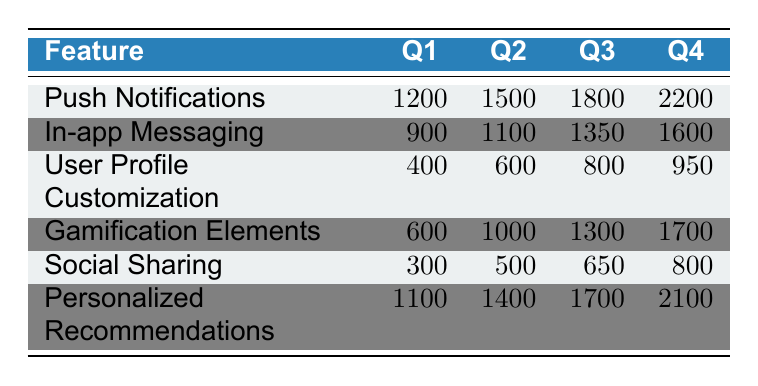What was the user engagement level for Push Notifications in Q3? Referring to the table, the engagement level for Push Notifications in Q3 is listed directly under the Q3 column for that feature. It shows a value of 1800.
Answer: 1800 Which feature had the lowest user engagement level in Q1? Upon reviewing the Q1 values for all features, User Profile Customization has the lowest value of 400, compared to the others.
Answer: User Profile Customization What is the total user engagement level for Gamification Elements over all quarters? To find the total, we add the values for Gamification Elements across all quarters: 600 + 1000 + 1300 + 1700 = 3600.
Answer: 3600 Is the user engagement level for In-app Messaging higher in Q2 than in Q3? Checking the values, In-app Messaging has 1100 in Q2 and 1350 in Q3, indicating that Q3 has a higher engagement level than Q2. Therefore, the statement is false.
Answer: No What is the average user engagement level for Personalized Recommendations across all quarters? To calculate the average, first add the values for all quarters: 1100 + 1400 + 1700 + 2100 = 6300. Then divide by the number of quarters (4): 6300 / 4 = 1575.
Answer: 1575 Which feature saw the highest increase in user engagement level from Q1 to Q4? The increase for each feature from Q1 to Q4 needs to be calculated: For Push Notifications: 2200 - 1200 = 1000; In-app Messaging: 1600 - 900 = 700; User Profile Customization: 950 - 400 = 550; Gamification Elements: 1700 - 600 = 1100; Social Sharing: 800 - 300 = 500; Personalized Recommendations: 2100 - 1100 = 1000. The largest increase is 1100 for Gamification Elements.
Answer: Gamification Elements Does Social Sharing have a higher engagement level in Q3 than User Profile Customization in Q4? Comparison shows Social Sharing at 650 in Q3 and User Profile Customization at 950 in Q4. Since 650 is less than 950, the statement is false.
Answer: No What is the difference in user engagement levels between Push Notifications in Q4 and Personalized Recommendations in Q1? Calculate the difference by subtracting Personalized Recommendations Q1 (1100) from Push Notifications Q4 (2200): 2200 - 1100 = 1100.
Answer: 1100 Which feature has engaged users more consistently across the quarters? By examining the increase from Q1 to Q4 for each feature, we find trends. Push Notifications stand out with consistent growth, going from 1200 to 2200. The steady increase implies it has engaged users more steadily versus others showing more volatility.
Answer: Push Notifications 